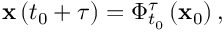<formula> <loc_0><loc_0><loc_500><loc_500>x \left ( t _ { 0 } + \tau \right ) = \Phi _ { t _ { 0 } } ^ { \tau } \left ( x _ { 0 } \right ) ,</formula> 